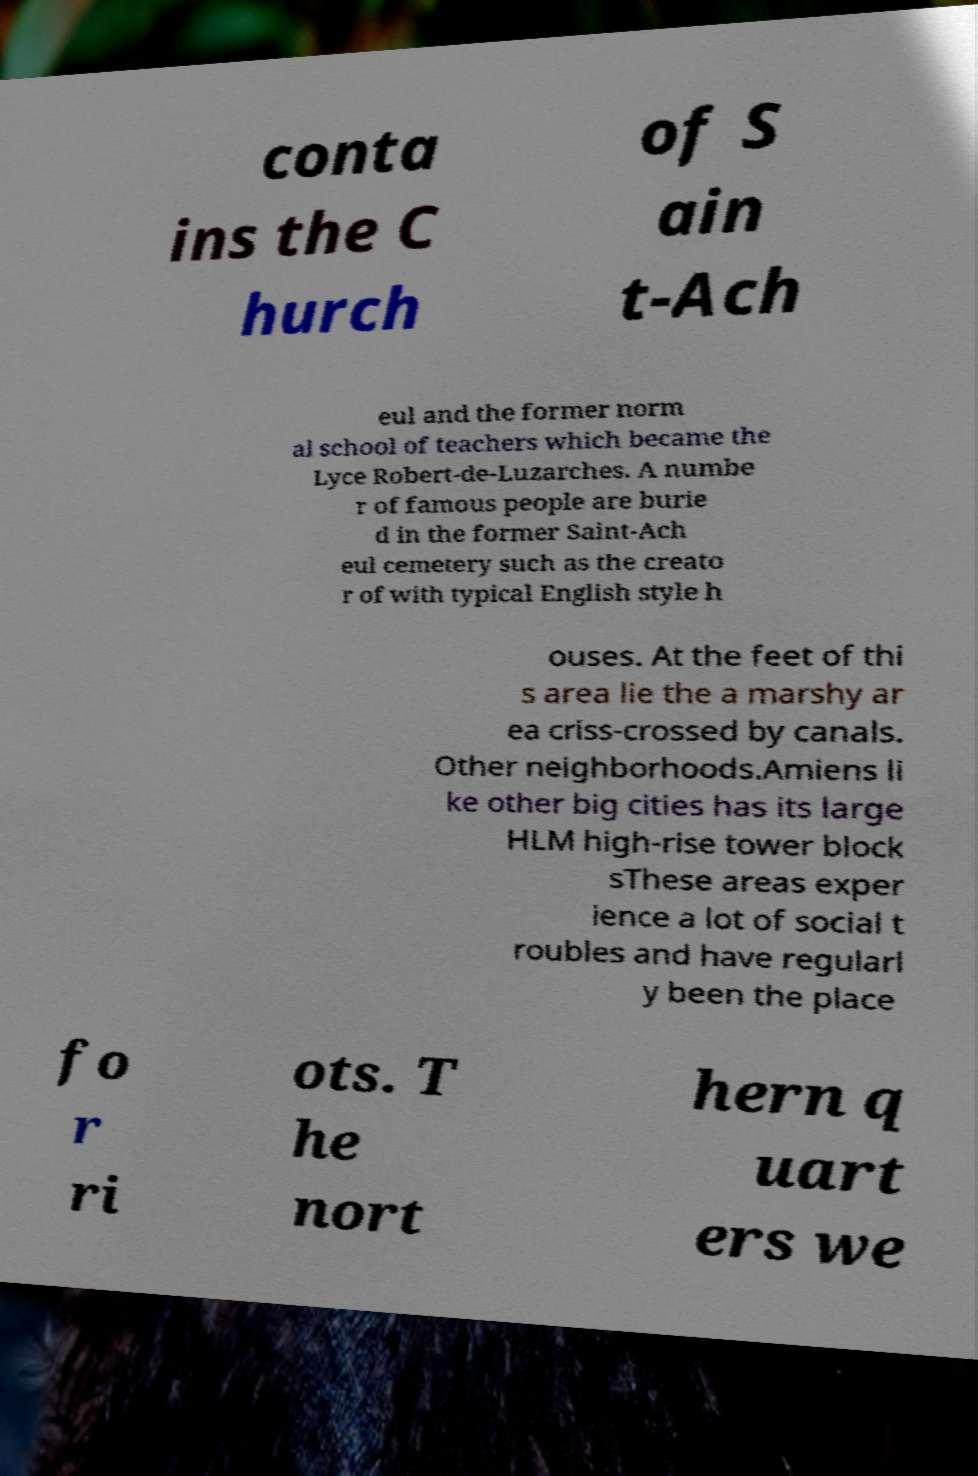For documentation purposes, I need the text within this image transcribed. Could you provide that? conta ins the C hurch of S ain t-Ach eul and the former norm al school of teachers which became the Lyce Robert-de-Luzarches. A numbe r of famous people are burie d in the former Saint-Ach eul cemetery such as the creato r of with typical English style h ouses. At the feet of thi s area lie the a marshy ar ea criss-crossed by canals. Other neighborhoods.Amiens li ke other big cities has its large HLM high-rise tower block sThese areas exper ience a lot of social t roubles and have regularl y been the place fo r ri ots. T he nort hern q uart ers we 